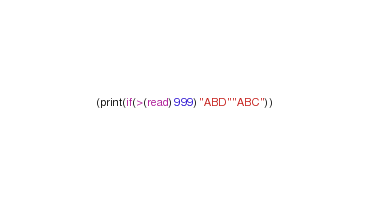<code> <loc_0><loc_0><loc_500><loc_500><_Scheme_>(print(if(>(read)999)"ABD""ABC"))</code> 